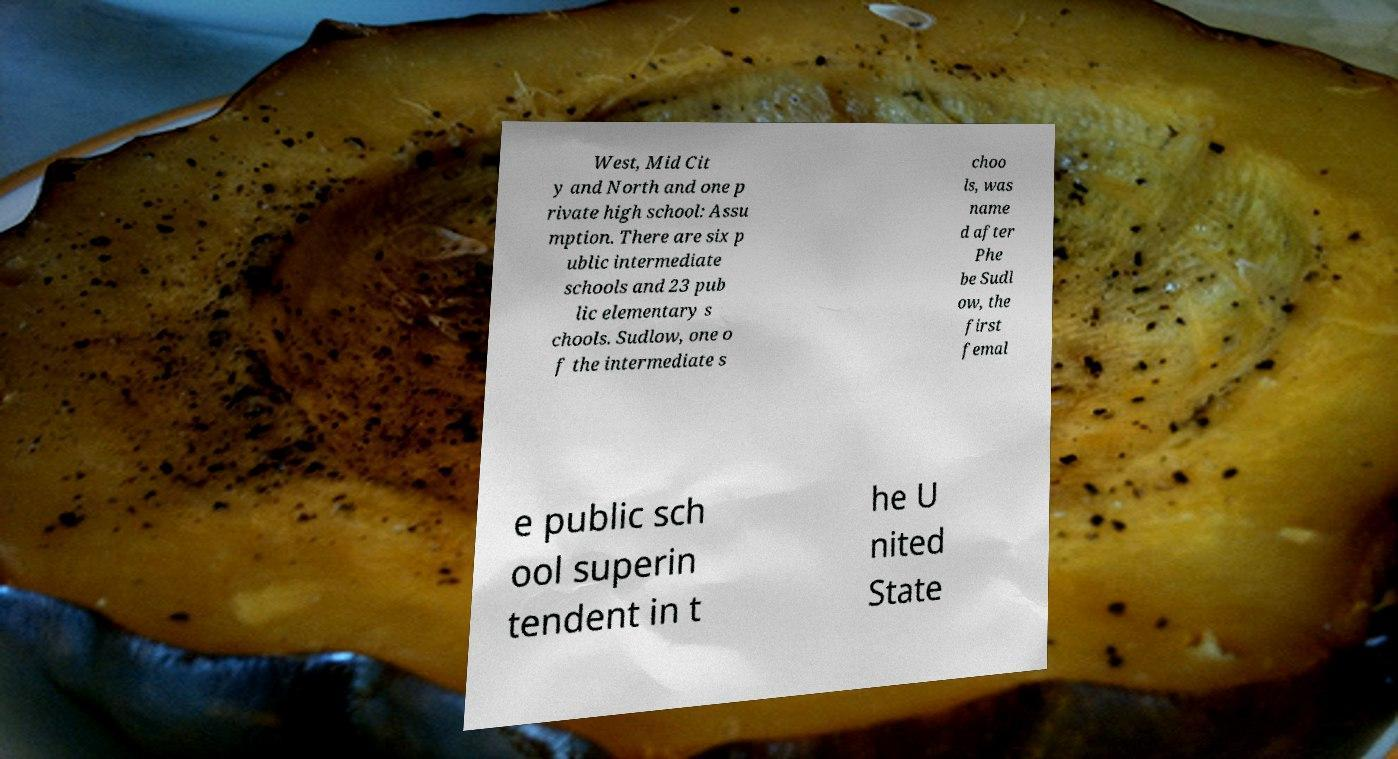Could you assist in decoding the text presented in this image and type it out clearly? West, Mid Cit y and North and one p rivate high school: Assu mption. There are six p ublic intermediate schools and 23 pub lic elementary s chools. Sudlow, one o f the intermediate s choo ls, was name d after Phe be Sudl ow, the first femal e public sch ool superin tendent in t he U nited State 